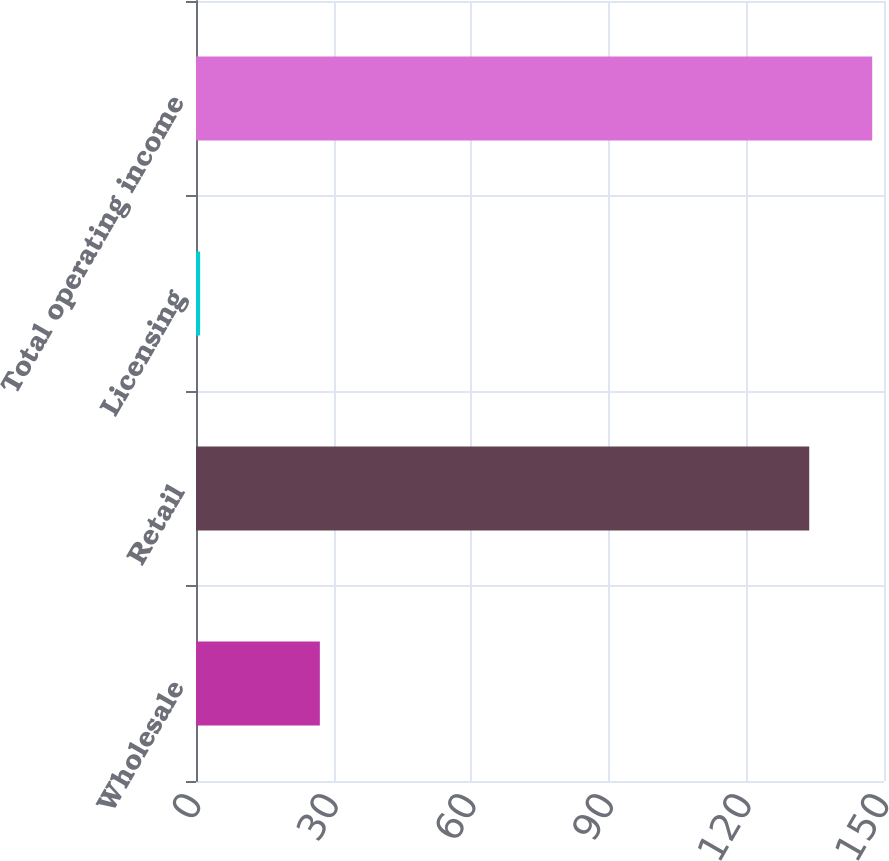Convert chart. <chart><loc_0><loc_0><loc_500><loc_500><bar_chart><fcel>Wholesale<fcel>Retail<fcel>Licensing<fcel>Total operating income<nl><fcel>27<fcel>133.7<fcel>0.9<fcel>147.43<nl></chart> 